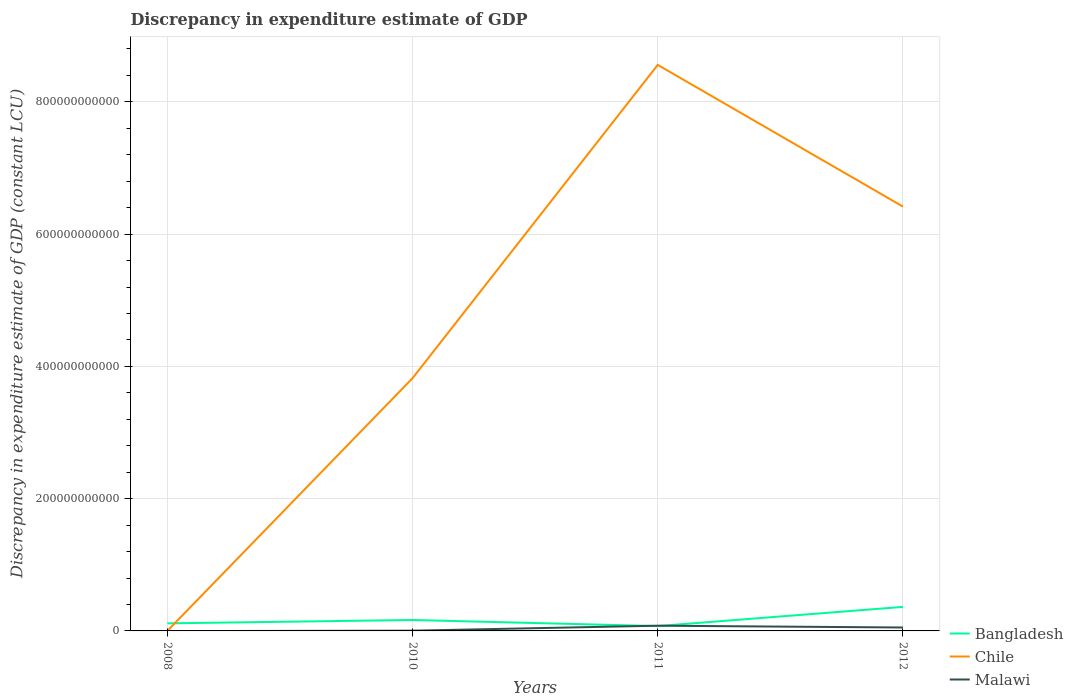How many different coloured lines are there?
Offer a terse response. 3. Is the number of lines equal to the number of legend labels?
Your answer should be very brief. No. Across all years, what is the maximum discrepancy in expenditure estimate of GDP in Bangladesh?
Ensure brevity in your answer.  7.32e+09. What is the total discrepancy in expenditure estimate of GDP in Malawi in the graph?
Offer a terse response. -4.81e+09. What is the difference between the highest and the second highest discrepancy in expenditure estimate of GDP in Chile?
Provide a succinct answer. 8.56e+11. What is the difference between the highest and the lowest discrepancy in expenditure estimate of GDP in Bangladesh?
Give a very brief answer. 1. Is the discrepancy in expenditure estimate of GDP in Chile strictly greater than the discrepancy in expenditure estimate of GDP in Bangladesh over the years?
Your answer should be very brief. No. How many lines are there?
Your response must be concise. 3. What is the difference between two consecutive major ticks on the Y-axis?
Your answer should be compact. 2.00e+11. Are the values on the major ticks of Y-axis written in scientific E-notation?
Provide a short and direct response. No. Where does the legend appear in the graph?
Provide a succinct answer. Bottom right. How many legend labels are there?
Offer a terse response. 3. What is the title of the graph?
Ensure brevity in your answer.  Discrepancy in expenditure estimate of GDP. Does "Yemen, Rep." appear as one of the legend labels in the graph?
Keep it short and to the point. No. What is the label or title of the Y-axis?
Your response must be concise. Discrepancy in expenditure estimate of GDP (constant LCU). What is the Discrepancy in expenditure estimate of GDP (constant LCU) in Bangladesh in 2008?
Keep it short and to the point. 1.14e+1. What is the Discrepancy in expenditure estimate of GDP (constant LCU) of Chile in 2008?
Ensure brevity in your answer.  0. What is the Discrepancy in expenditure estimate of GDP (constant LCU) of Bangladesh in 2010?
Keep it short and to the point. 1.65e+1. What is the Discrepancy in expenditure estimate of GDP (constant LCU) of Chile in 2010?
Your response must be concise. 3.82e+11. What is the Discrepancy in expenditure estimate of GDP (constant LCU) in Malawi in 2010?
Make the answer very short. 3.71e+08. What is the Discrepancy in expenditure estimate of GDP (constant LCU) in Bangladesh in 2011?
Offer a terse response. 7.32e+09. What is the Discrepancy in expenditure estimate of GDP (constant LCU) of Chile in 2011?
Provide a short and direct response. 8.56e+11. What is the Discrepancy in expenditure estimate of GDP (constant LCU) of Malawi in 2011?
Your response must be concise. 7.91e+09. What is the Discrepancy in expenditure estimate of GDP (constant LCU) in Bangladesh in 2012?
Provide a short and direct response. 3.63e+1. What is the Discrepancy in expenditure estimate of GDP (constant LCU) of Chile in 2012?
Offer a very short reply. 6.42e+11. What is the Discrepancy in expenditure estimate of GDP (constant LCU) in Malawi in 2012?
Provide a short and direct response. 5.18e+09. Across all years, what is the maximum Discrepancy in expenditure estimate of GDP (constant LCU) in Bangladesh?
Your answer should be very brief. 3.63e+1. Across all years, what is the maximum Discrepancy in expenditure estimate of GDP (constant LCU) of Chile?
Make the answer very short. 8.56e+11. Across all years, what is the maximum Discrepancy in expenditure estimate of GDP (constant LCU) of Malawi?
Ensure brevity in your answer.  7.91e+09. Across all years, what is the minimum Discrepancy in expenditure estimate of GDP (constant LCU) in Bangladesh?
Make the answer very short. 7.32e+09. Across all years, what is the minimum Discrepancy in expenditure estimate of GDP (constant LCU) in Malawi?
Offer a very short reply. 0. What is the total Discrepancy in expenditure estimate of GDP (constant LCU) in Bangladesh in the graph?
Offer a terse response. 7.16e+1. What is the total Discrepancy in expenditure estimate of GDP (constant LCU) of Chile in the graph?
Offer a terse response. 1.88e+12. What is the total Discrepancy in expenditure estimate of GDP (constant LCU) of Malawi in the graph?
Give a very brief answer. 1.35e+1. What is the difference between the Discrepancy in expenditure estimate of GDP (constant LCU) of Bangladesh in 2008 and that in 2010?
Ensure brevity in your answer.  -5.10e+09. What is the difference between the Discrepancy in expenditure estimate of GDP (constant LCU) of Bangladesh in 2008 and that in 2011?
Your response must be concise. 4.11e+09. What is the difference between the Discrepancy in expenditure estimate of GDP (constant LCU) in Bangladesh in 2008 and that in 2012?
Ensure brevity in your answer.  -2.49e+1. What is the difference between the Discrepancy in expenditure estimate of GDP (constant LCU) in Bangladesh in 2010 and that in 2011?
Provide a short and direct response. 9.21e+09. What is the difference between the Discrepancy in expenditure estimate of GDP (constant LCU) in Chile in 2010 and that in 2011?
Offer a very short reply. -4.74e+11. What is the difference between the Discrepancy in expenditure estimate of GDP (constant LCU) in Malawi in 2010 and that in 2011?
Keep it short and to the point. -7.54e+09. What is the difference between the Discrepancy in expenditure estimate of GDP (constant LCU) in Bangladesh in 2010 and that in 2012?
Your answer should be very brief. -1.98e+1. What is the difference between the Discrepancy in expenditure estimate of GDP (constant LCU) of Chile in 2010 and that in 2012?
Your answer should be very brief. -2.59e+11. What is the difference between the Discrepancy in expenditure estimate of GDP (constant LCU) of Malawi in 2010 and that in 2012?
Your response must be concise. -4.81e+09. What is the difference between the Discrepancy in expenditure estimate of GDP (constant LCU) in Bangladesh in 2011 and that in 2012?
Your answer should be very brief. -2.90e+1. What is the difference between the Discrepancy in expenditure estimate of GDP (constant LCU) of Chile in 2011 and that in 2012?
Give a very brief answer. 2.14e+11. What is the difference between the Discrepancy in expenditure estimate of GDP (constant LCU) in Malawi in 2011 and that in 2012?
Keep it short and to the point. 2.73e+09. What is the difference between the Discrepancy in expenditure estimate of GDP (constant LCU) of Bangladesh in 2008 and the Discrepancy in expenditure estimate of GDP (constant LCU) of Chile in 2010?
Offer a terse response. -3.71e+11. What is the difference between the Discrepancy in expenditure estimate of GDP (constant LCU) in Bangladesh in 2008 and the Discrepancy in expenditure estimate of GDP (constant LCU) in Malawi in 2010?
Give a very brief answer. 1.11e+1. What is the difference between the Discrepancy in expenditure estimate of GDP (constant LCU) in Bangladesh in 2008 and the Discrepancy in expenditure estimate of GDP (constant LCU) in Chile in 2011?
Offer a very short reply. -8.44e+11. What is the difference between the Discrepancy in expenditure estimate of GDP (constant LCU) of Bangladesh in 2008 and the Discrepancy in expenditure estimate of GDP (constant LCU) of Malawi in 2011?
Your answer should be compact. 3.52e+09. What is the difference between the Discrepancy in expenditure estimate of GDP (constant LCU) of Bangladesh in 2008 and the Discrepancy in expenditure estimate of GDP (constant LCU) of Chile in 2012?
Offer a terse response. -6.30e+11. What is the difference between the Discrepancy in expenditure estimate of GDP (constant LCU) in Bangladesh in 2008 and the Discrepancy in expenditure estimate of GDP (constant LCU) in Malawi in 2012?
Provide a succinct answer. 6.25e+09. What is the difference between the Discrepancy in expenditure estimate of GDP (constant LCU) in Bangladesh in 2010 and the Discrepancy in expenditure estimate of GDP (constant LCU) in Chile in 2011?
Offer a terse response. -8.39e+11. What is the difference between the Discrepancy in expenditure estimate of GDP (constant LCU) in Bangladesh in 2010 and the Discrepancy in expenditure estimate of GDP (constant LCU) in Malawi in 2011?
Offer a terse response. 8.62e+09. What is the difference between the Discrepancy in expenditure estimate of GDP (constant LCU) in Chile in 2010 and the Discrepancy in expenditure estimate of GDP (constant LCU) in Malawi in 2011?
Your response must be concise. 3.74e+11. What is the difference between the Discrepancy in expenditure estimate of GDP (constant LCU) in Bangladesh in 2010 and the Discrepancy in expenditure estimate of GDP (constant LCU) in Chile in 2012?
Your answer should be very brief. -6.25e+11. What is the difference between the Discrepancy in expenditure estimate of GDP (constant LCU) of Bangladesh in 2010 and the Discrepancy in expenditure estimate of GDP (constant LCU) of Malawi in 2012?
Offer a terse response. 1.13e+1. What is the difference between the Discrepancy in expenditure estimate of GDP (constant LCU) in Chile in 2010 and the Discrepancy in expenditure estimate of GDP (constant LCU) in Malawi in 2012?
Your answer should be very brief. 3.77e+11. What is the difference between the Discrepancy in expenditure estimate of GDP (constant LCU) of Bangladesh in 2011 and the Discrepancy in expenditure estimate of GDP (constant LCU) of Chile in 2012?
Give a very brief answer. -6.34e+11. What is the difference between the Discrepancy in expenditure estimate of GDP (constant LCU) in Bangladesh in 2011 and the Discrepancy in expenditure estimate of GDP (constant LCU) in Malawi in 2012?
Your answer should be very brief. 2.14e+09. What is the difference between the Discrepancy in expenditure estimate of GDP (constant LCU) of Chile in 2011 and the Discrepancy in expenditure estimate of GDP (constant LCU) of Malawi in 2012?
Your answer should be very brief. 8.51e+11. What is the average Discrepancy in expenditure estimate of GDP (constant LCU) of Bangladesh per year?
Give a very brief answer. 1.79e+1. What is the average Discrepancy in expenditure estimate of GDP (constant LCU) in Chile per year?
Provide a succinct answer. 4.70e+11. What is the average Discrepancy in expenditure estimate of GDP (constant LCU) of Malawi per year?
Offer a terse response. 3.37e+09. In the year 2010, what is the difference between the Discrepancy in expenditure estimate of GDP (constant LCU) of Bangladesh and Discrepancy in expenditure estimate of GDP (constant LCU) of Chile?
Provide a succinct answer. -3.66e+11. In the year 2010, what is the difference between the Discrepancy in expenditure estimate of GDP (constant LCU) of Bangladesh and Discrepancy in expenditure estimate of GDP (constant LCU) of Malawi?
Offer a terse response. 1.62e+1. In the year 2010, what is the difference between the Discrepancy in expenditure estimate of GDP (constant LCU) in Chile and Discrepancy in expenditure estimate of GDP (constant LCU) in Malawi?
Provide a short and direct response. 3.82e+11. In the year 2011, what is the difference between the Discrepancy in expenditure estimate of GDP (constant LCU) of Bangladesh and Discrepancy in expenditure estimate of GDP (constant LCU) of Chile?
Give a very brief answer. -8.49e+11. In the year 2011, what is the difference between the Discrepancy in expenditure estimate of GDP (constant LCU) in Bangladesh and Discrepancy in expenditure estimate of GDP (constant LCU) in Malawi?
Offer a terse response. -5.90e+08. In the year 2011, what is the difference between the Discrepancy in expenditure estimate of GDP (constant LCU) in Chile and Discrepancy in expenditure estimate of GDP (constant LCU) in Malawi?
Make the answer very short. 8.48e+11. In the year 2012, what is the difference between the Discrepancy in expenditure estimate of GDP (constant LCU) of Bangladesh and Discrepancy in expenditure estimate of GDP (constant LCU) of Chile?
Offer a very short reply. -6.05e+11. In the year 2012, what is the difference between the Discrepancy in expenditure estimate of GDP (constant LCU) of Bangladesh and Discrepancy in expenditure estimate of GDP (constant LCU) of Malawi?
Provide a short and direct response. 3.12e+1. In the year 2012, what is the difference between the Discrepancy in expenditure estimate of GDP (constant LCU) in Chile and Discrepancy in expenditure estimate of GDP (constant LCU) in Malawi?
Offer a terse response. 6.36e+11. What is the ratio of the Discrepancy in expenditure estimate of GDP (constant LCU) of Bangladesh in 2008 to that in 2010?
Your answer should be very brief. 0.69. What is the ratio of the Discrepancy in expenditure estimate of GDP (constant LCU) of Bangladesh in 2008 to that in 2011?
Offer a terse response. 1.56. What is the ratio of the Discrepancy in expenditure estimate of GDP (constant LCU) in Bangladesh in 2008 to that in 2012?
Offer a terse response. 0.31. What is the ratio of the Discrepancy in expenditure estimate of GDP (constant LCU) of Bangladesh in 2010 to that in 2011?
Keep it short and to the point. 2.26. What is the ratio of the Discrepancy in expenditure estimate of GDP (constant LCU) of Chile in 2010 to that in 2011?
Your response must be concise. 0.45. What is the ratio of the Discrepancy in expenditure estimate of GDP (constant LCU) of Malawi in 2010 to that in 2011?
Your response must be concise. 0.05. What is the ratio of the Discrepancy in expenditure estimate of GDP (constant LCU) in Bangladesh in 2010 to that in 2012?
Provide a succinct answer. 0.45. What is the ratio of the Discrepancy in expenditure estimate of GDP (constant LCU) of Chile in 2010 to that in 2012?
Make the answer very short. 0.6. What is the ratio of the Discrepancy in expenditure estimate of GDP (constant LCU) of Malawi in 2010 to that in 2012?
Your response must be concise. 0.07. What is the ratio of the Discrepancy in expenditure estimate of GDP (constant LCU) in Bangladesh in 2011 to that in 2012?
Provide a succinct answer. 0.2. What is the ratio of the Discrepancy in expenditure estimate of GDP (constant LCU) of Chile in 2011 to that in 2012?
Make the answer very short. 1.33. What is the ratio of the Discrepancy in expenditure estimate of GDP (constant LCU) of Malawi in 2011 to that in 2012?
Give a very brief answer. 1.53. What is the difference between the highest and the second highest Discrepancy in expenditure estimate of GDP (constant LCU) in Bangladesh?
Give a very brief answer. 1.98e+1. What is the difference between the highest and the second highest Discrepancy in expenditure estimate of GDP (constant LCU) of Chile?
Offer a very short reply. 2.14e+11. What is the difference between the highest and the second highest Discrepancy in expenditure estimate of GDP (constant LCU) of Malawi?
Your answer should be compact. 2.73e+09. What is the difference between the highest and the lowest Discrepancy in expenditure estimate of GDP (constant LCU) in Bangladesh?
Make the answer very short. 2.90e+1. What is the difference between the highest and the lowest Discrepancy in expenditure estimate of GDP (constant LCU) in Chile?
Give a very brief answer. 8.56e+11. What is the difference between the highest and the lowest Discrepancy in expenditure estimate of GDP (constant LCU) of Malawi?
Make the answer very short. 7.91e+09. 